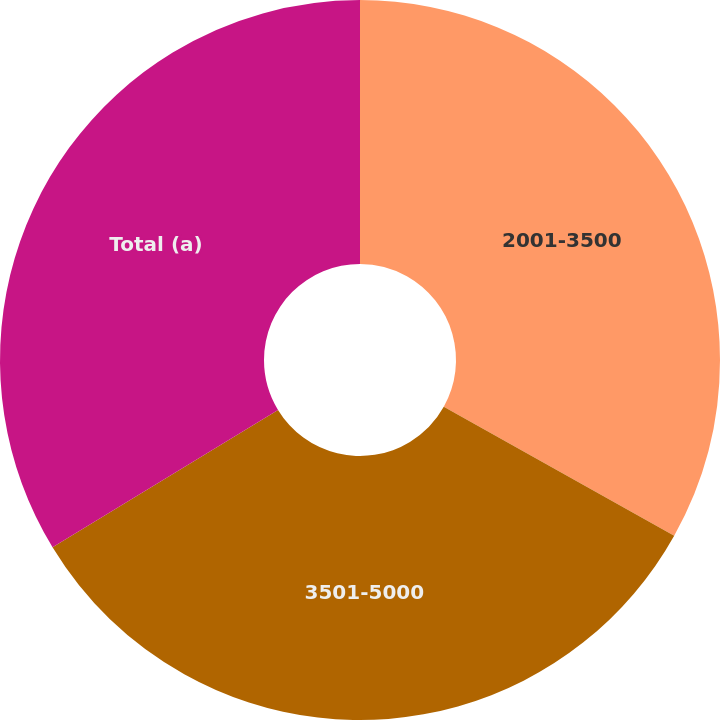<chart> <loc_0><loc_0><loc_500><loc_500><pie_chart><fcel>2001-3500<fcel>3501-5000<fcel>Total (a)<nl><fcel>33.12%<fcel>33.18%<fcel>33.71%<nl></chart> 